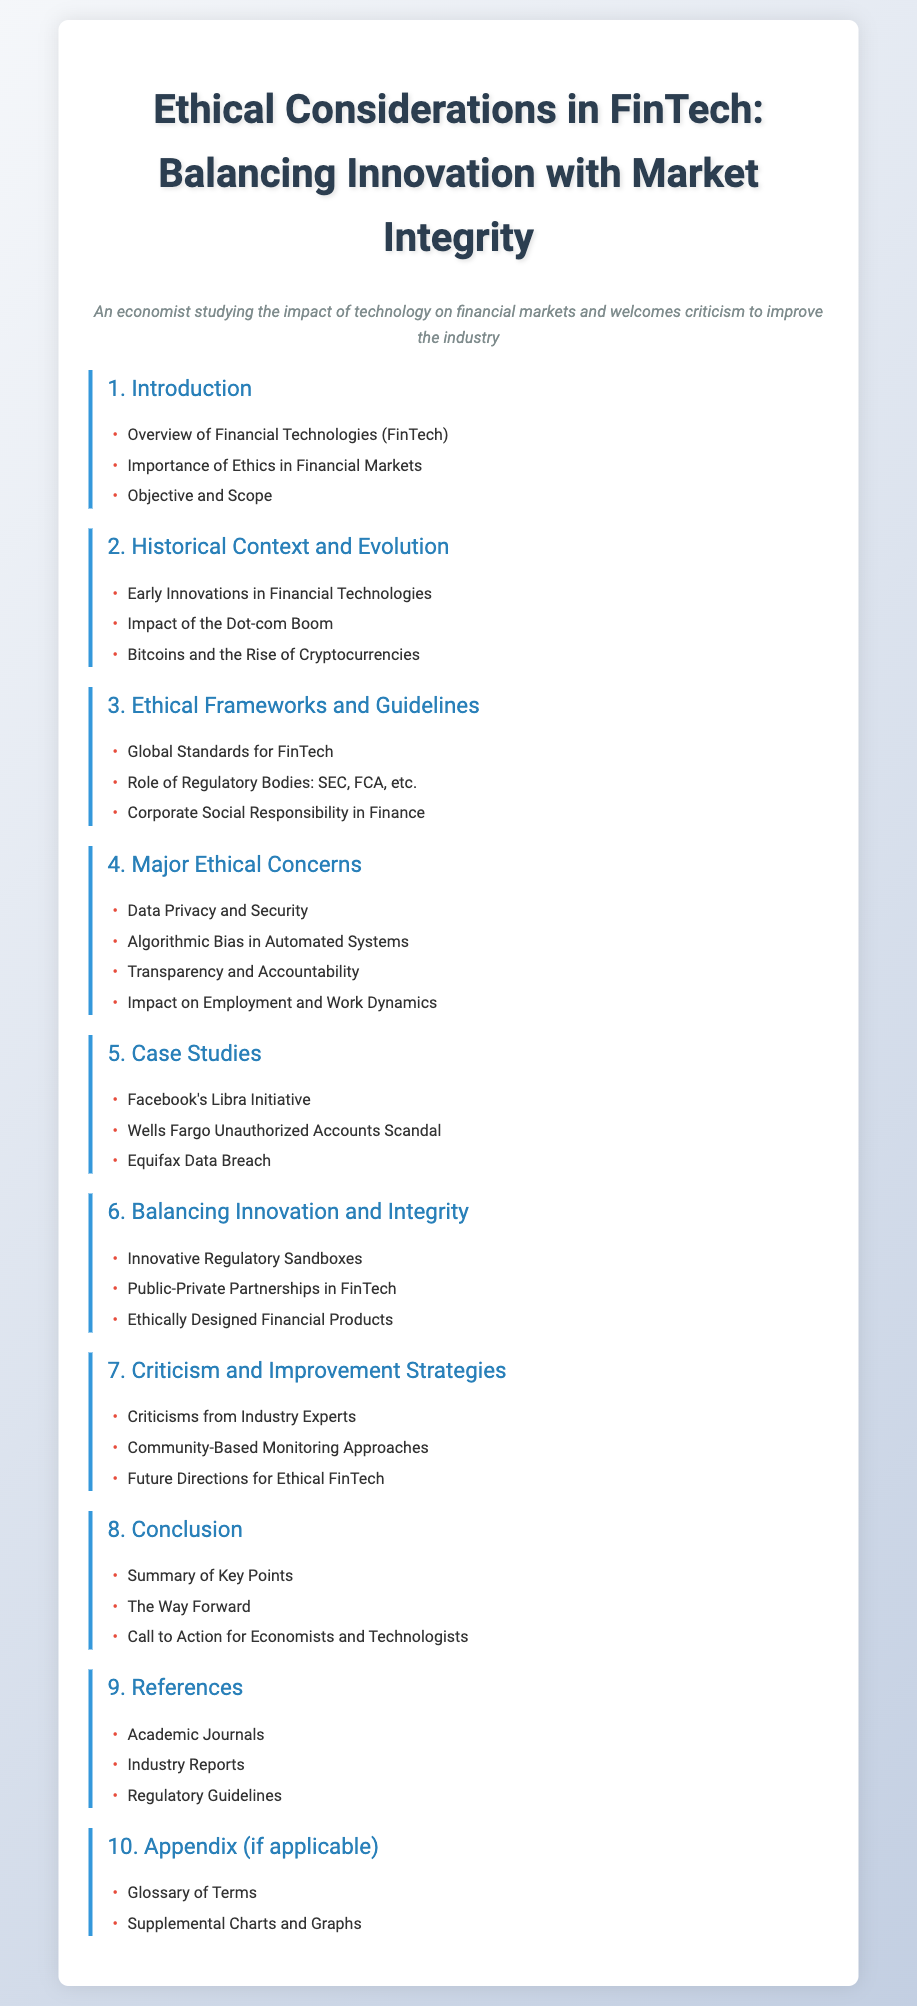What is the title of the document? The title is mentioned prominently at the top of the document, indicating the subject matter.
Answer: Ethical Considerations in FinTech: Balancing Innovation with Market Integrity What chapter discusses Ethical Frameworks? The chapter titles provide insights into the topics covered; this particular chapter directly addresses ethical guidelines.
Answer: Chapter 3 How many major ethical concerns are listed? The number of items listed under Major Ethical Concerns provides a count of issues addressed in that chapter.
Answer: Four Which case study involves a data breach? The section item titles specify the case studies, one of which focuses on a significant data security issue.
Answer: Equifax Data Breach What is mentioned as a future direction for ethical FinTech? Future strategies are highlighted in the last chapter, indicating intended growth or changes in this area.
Answer: Future Directions for Ethical FinTech Which chapter contains a call to action? The conclusion typically summarizes key findings and may include actionable items, making it an essential section for readers.
Answer: Chapter 8 What regulatory bodies are mentioned in the ethical guidelines? The chapter discusses specific organizations that play a critical role in overseeing ethical practices in financial technology.
Answer: SEC, FCA What is the focus of the introductory chapter? The introduction sets the stage for the discussion by explaining foundational concepts and importance.
Answer: Overview of Financial Technologies (FinTech) What does the appendix potentially include? The appendix usually contains supplementary material to enhance understanding of the document content.
Answer: Glossary of Terms How many chapters are there in total? The total number of chapters is evident from the structured outline of content provided in the document.
Answer: Ten 